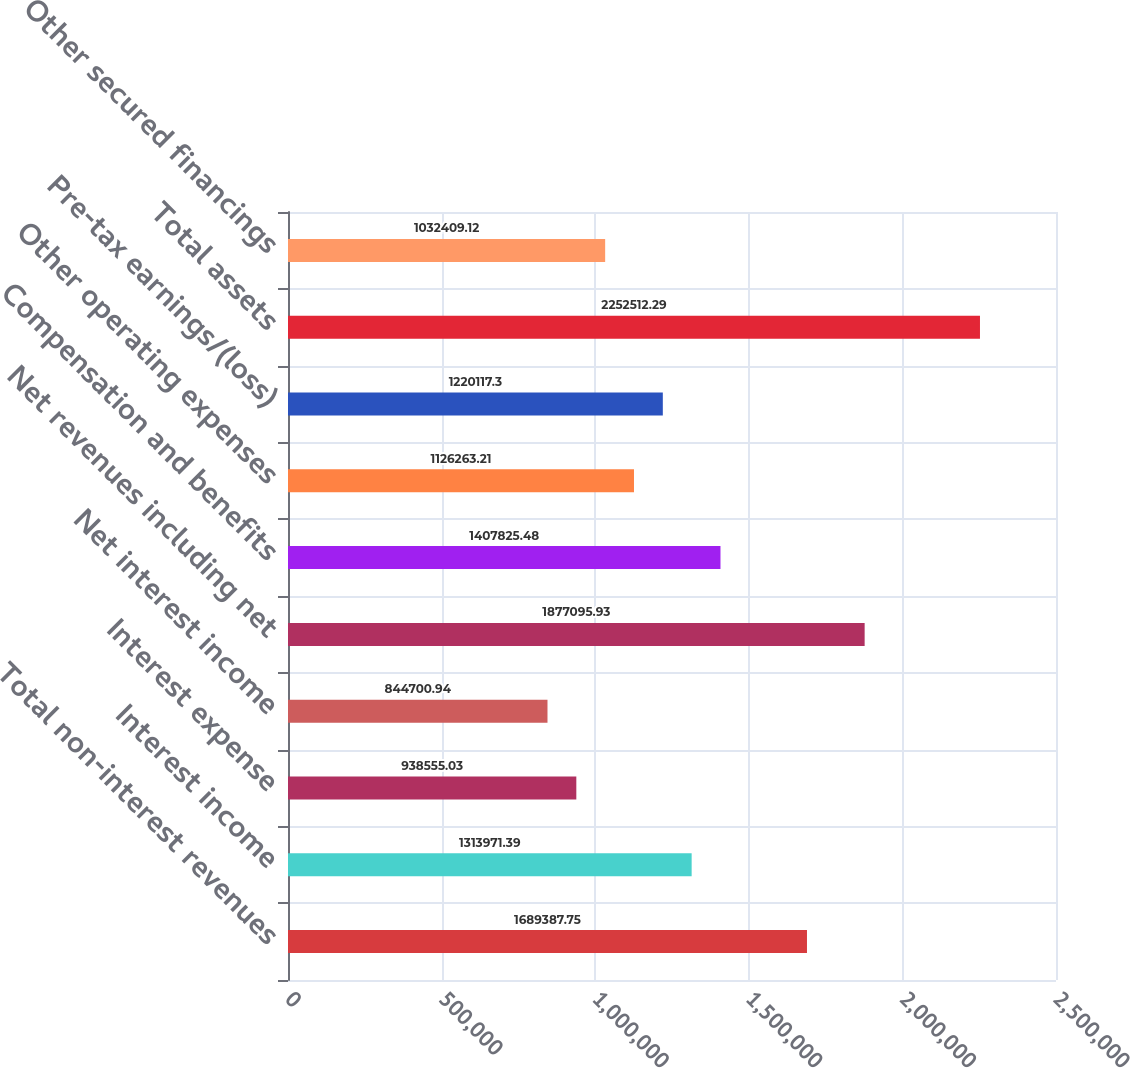Convert chart to OTSL. <chart><loc_0><loc_0><loc_500><loc_500><bar_chart><fcel>Total non-interest revenues<fcel>Interest income<fcel>Interest expense<fcel>Net interest income<fcel>Net revenues including net<fcel>Compensation and benefits<fcel>Other operating expenses<fcel>Pre-tax earnings/(loss)<fcel>Total assets<fcel>Other secured financings<nl><fcel>1.68939e+06<fcel>1.31397e+06<fcel>938555<fcel>844701<fcel>1.8771e+06<fcel>1.40783e+06<fcel>1.12626e+06<fcel>1.22012e+06<fcel>2.25251e+06<fcel>1.03241e+06<nl></chart> 